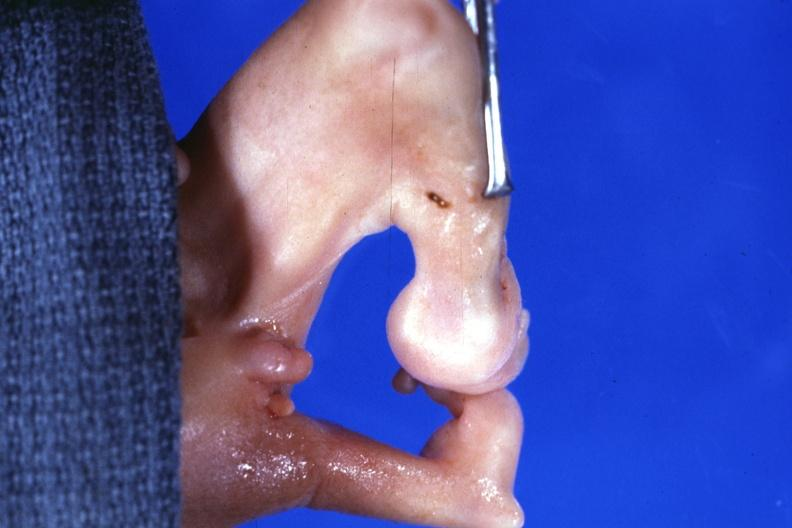does this image show marked deformity both legs?
Answer the question using a single word or phrase. Yes 